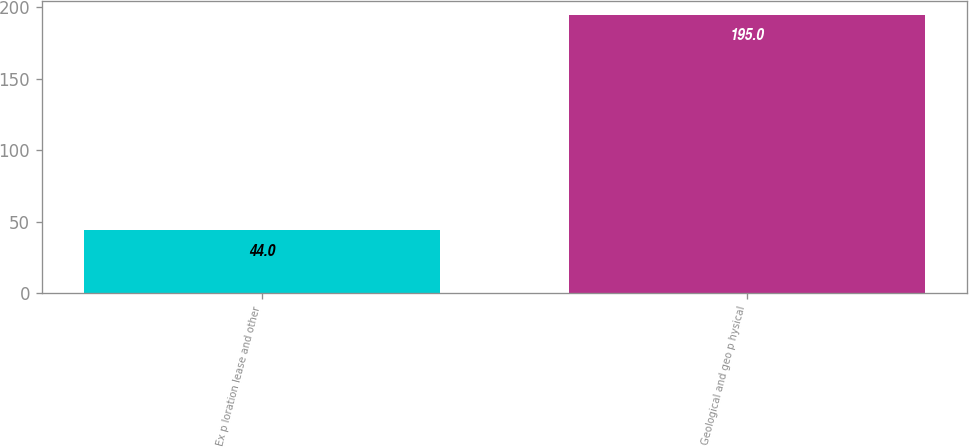<chart> <loc_0><loc_0><loc_500><loc_500><bar_chart><fcel>Ex p loration lease and other<fcel>Geological and geo p hysical<nl><fcel>44<fcel>195<nl></chart> 